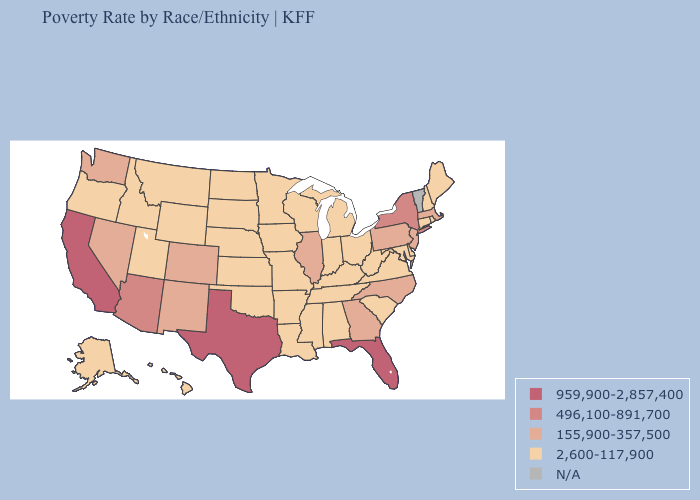Does the first symbol in the legend represent the smallest category?
Be succinct. No. What is the value of Maine?
Concise answer only. 2,600-117,900. Which states hav the highest value in the Northeast?
Quick response, please. New York. What is the lowest value in the MidWest?
Answer briefly. 2,600-117,900. Which states have the lowest value in the West?
Short answer required. Alaska, Hawaii, Idaho, Montana, Oregon, Utah, Wyoming. What is the value of California?
Write a very short answer. 959,900-2,857,400. Which states hav the highest value in the MidWest?
Answer briefly. Illinois. Name the states that have a value in the range 496,100-891,700?
Keep it brief. Arizona, New York. What is the value of Michigan?
Give a very brief answer. 2,600-117,900. Which states hav the highest value in the MidWest?
Be succinct. Illinois. What is the highest value in the USA?
Answer briefly. 959,900-2,857,400. What is the value of Texas?
Give a very brief answer. 959,900-2,857,400. What is the value of Montana?
Keep it brief. 2,600-117,900. 